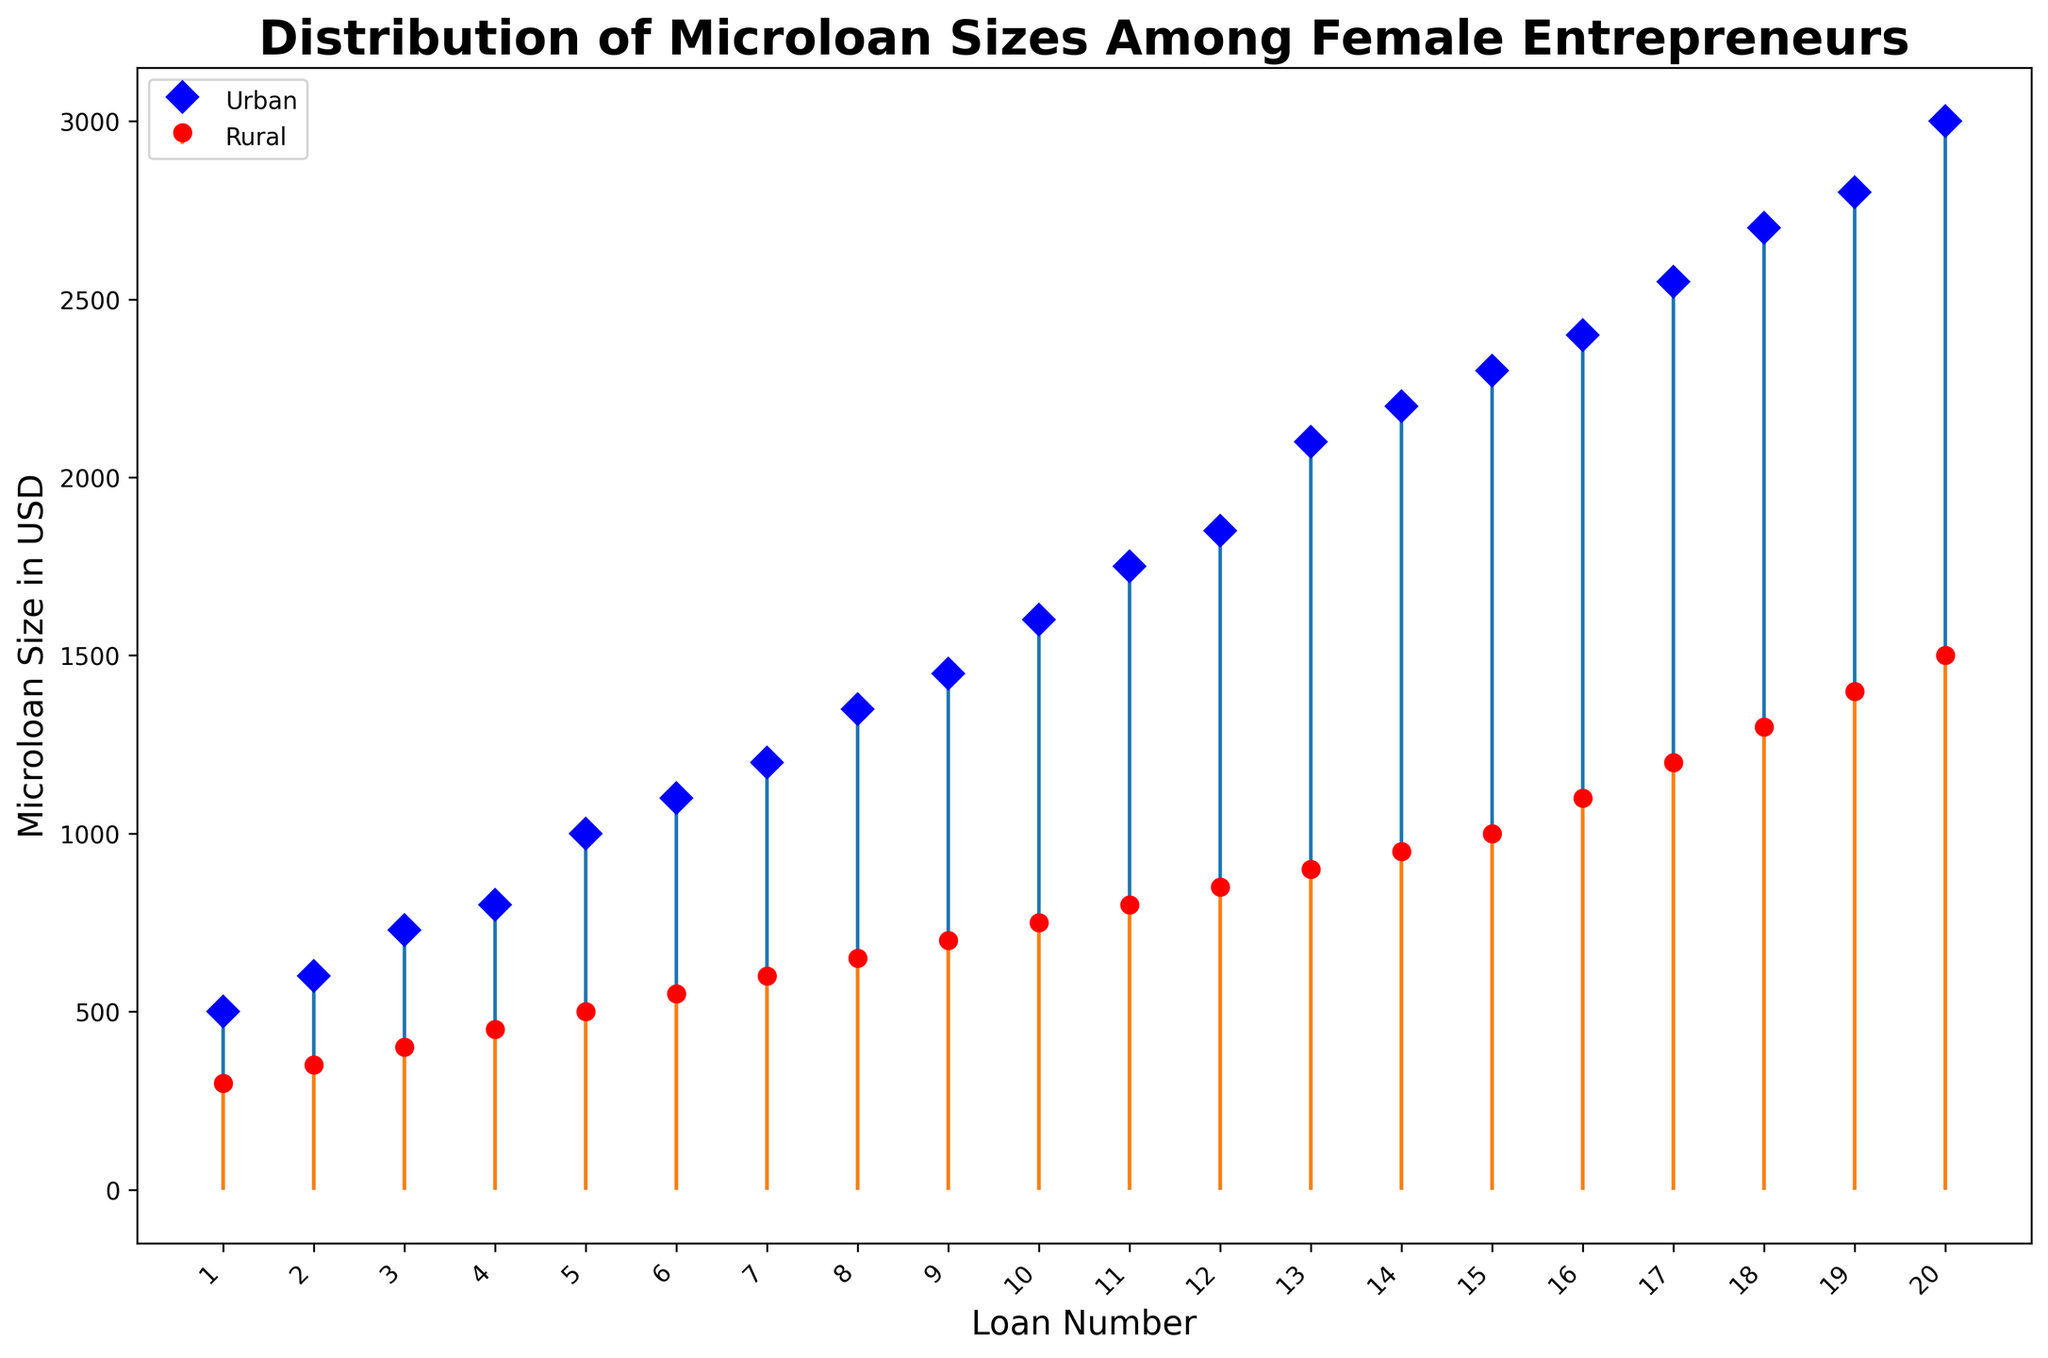What is the highest microloan size in urban regions? Upon examining the figure, the tallest stem in the 'Urban' group represents the highest microloan size.
Answer: 3000 What is the range of microloan sizes in rural regions? The range is calculated by subtracting the smallest value from the largest value in the 'Rural' group. Identify the highest stem (1500) and the lowest stem (300) based on the plot and subtract them: 1500 - 300 = 1200.
Answer: 1200 How do the average microloan sizes compare between urban and rural regions? To compare averages, first estimate the average microloan size in each region by finding the central tendency of the distributions shown. The urban region has more high-value microloans compared to rural regions, making the overall average higher in urban regions.
Answer: Urban regions have a higher average microloan size than rural regions Are there more microloans given in urban or rural regions? Count the number of stems in each group. Urban has 20 stems, and rural has 20 stems, meaning both have received an equal number of microloans.
Answer: Equal Which region shows more variability in microloan sizes? Variability can be seen from the spread of the stems. Urban region stems are more spread out across a wider range, indicating higher variability.
Answer: Urban What is the median microloan size in rural regions? The median value is the middle data point when arranged in order. With 20 data points, the median is the average of the 10th and 11th values in the plot: (800 + 850) / 2 = 825.
Answer: 825 By how much does the highest microloan size exceed the median in urban regions? Determine the highest value (3000) and the median (the average of the 10th and 11th values: (1750 + 1850)/2 = 1800). Subtract the median from the highest value: 3000 - 1800 = 1200.
Answer: 1200 What can be inferred about the general level of microloan sizes when comparing urban and rural distributions visually? Both urban and rural distributions show ascending loan sizes but urban microloans are notably larger on average, which can be inferred from the heights of the stems rising higher in the urban plot compared to the rural one.
Answer: Urban microloans are generally larger 